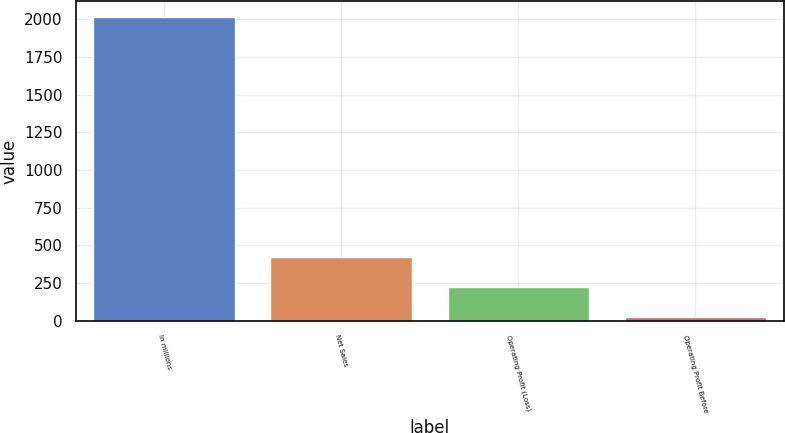Convert chart to OTSL. <chart><loc_0><loc_0><loc_500><loc_500><bar_chart><fcel>In millions<fcel>Net Sales<fcel>Operating Profit (Loss)<fcel>Operating Profit Before<nl><fcel>2017<fcel>423.4<fcel>224.2<fcel>25<nl></chart> 